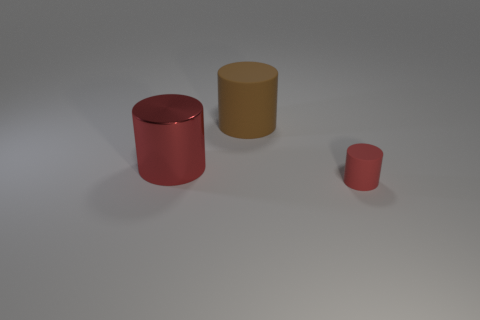Add 2 small cylinders. How many objects exist? 5 Add 2 brown things. How many brown things are left? 3 Add 3 large brown matte cylinders. How many large brown matte cylinders exist? 4 Subtract 0 blue balls. How many objects are left? 3 Subtract all large cyan spheres. Subtract all big brown rubber things. How many objects are left? 2 